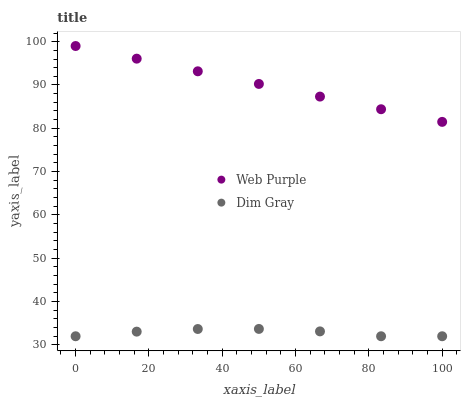Does Dim Gray have the minimum area under the curve?
Answer yes or no. Yes. Does Web Purple have the maximum area under the curve?
Answer yes or no. Yes. Does Dim Gray have the maximum area under the curve?
Answer yes or no. No. Is Web Purple the smoothest?
Answer yes or no. Yes. Is Dim Gray the roughest?
Answer yes or no. Yes. Is Dim Gray the smoothest?
Answer yes or no. No. Does Dim Gray have the lowest value?
Answer yes or no. Yes. Does Web Purple have the highest value?
Answer yes or no. Yes. Does Dim Gray have the highest value?
Answer yes or no. No. Is Dim Gray less than Web Purple?
Answer yes or no. Yes. Is Web Purple greater than Dim Gray?
Answer yes or no. Yes. Does Dim Gray intersect Web Purple?
Answer yes or no. No. 